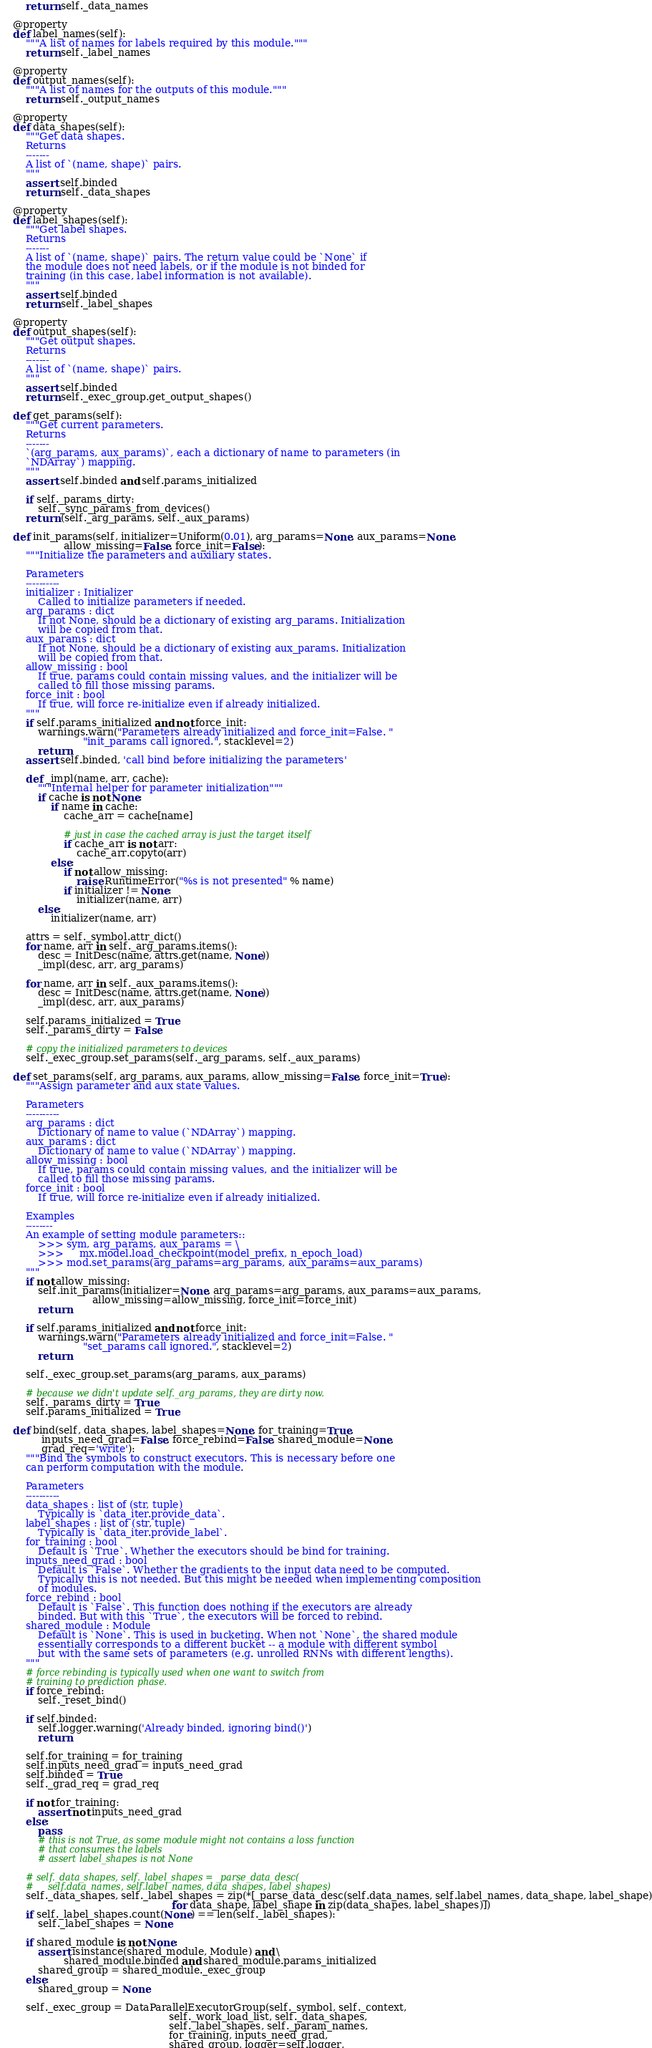Convert code to text. <code><loc_0><loc_0><loc_500><loc_500><_Python_>        return self._data_names

    @property
    def label_names(self):
        """A list of names for labels required by this module."""
        return self._label_names

    @property
    def output_names(self):
        """A list of names for the outputs of this module."""
        return self._output_names

    @property
    def data_shapes(self):
        """Get data shapes.
        Returns
        -------
        A list of `(name, shape)` pairs.
        """
        assert self.binded
        return self._data_shapes

    @property
    def label_shapes(self):
        """Get label shapes.
        Returns
        -------
        A list of `(name, shape)` pairs. The return value could be `None` if
        the module does not need labels, or if the module is not binded for
        training (in this case, label information is not available).
        """
        assert self.binded
        return self._label_shapes

    @property
    def output_shapes(self):
        """Get output shapes.
        Returns
        -------
        A list of `(name, shape)` pairs.
        """
        assert self.binded
        return self._exec_group.get_output_shapes()

    def get_params(self):
        """Get current parameters.
        Returns
        -------
        `(arg_params, aux_params)`, each a dictionary of name to parameters (in
        `NDArray`) mapping.
        """
        assert self.binded and self.params_initialized

        if self._params_dirty:
            self._sync_params_from_devices()
        return (self._arg_params, self._aux_params)

    def init_params(self, initializer=Uniform(0.01), arg_params=None, aux_params=None,
                    allow_missing=False, force_init=False):
        """Initialize the parameters and auxiliary states.

        Parameters
        ----------
        initializer : Initializer
            Called to initialize parameters if needed.
        arg_params : dict
            If not None, should be a dictionary of existing arg_params. Initialization
            will be copied from that.
        aux_params : dict
            If not None, should be a dictionary of existing aux_params. Initialization
            will be copied from that.
        allow_missing : bool
            If true, params could contain missing values, and the initializer will be
            called to fill those missing params.
        force_init : bool
            If true, will force re-initialize even if already initialized.
        """
        if self.params_initialized and not force_init:
            warnings.warn("Parameters already initialized and force_init=False. "
                          "init_params call ignored.", stacklevel=2)
            return
        assert self.binded, 'call bind before initializing the parameters'

        def _impl(name, arr, cache):
            """Internal helper for parameter initialization"""
            if cache is not None:
                if name in cache:
                    cache_arr = cache[name]

                    # just in case the cached array is just the target itself
                    if cache_arr is not arr:
                        cache_arr.copyto(arr)
                else:
                    if not allow_missing:
                        raise RuntimeError("%s is not presented" % name)
                    if initializer != None:
                        initializer(name, arr)
            else:
                initializer(name, arr)

        attrs = self._symbol.attr_dict()
        for name, arr in self._arg_params.items():
            desc = InitDesc(name, attrs.get(name, None))
            _impl(desc, arr, arg_params)

        for name, arr in self._aux_params.items():
            desc = InitDesc(name, attrs.get(name, None))
            _impl(desc, arr, aux_params)

        self.params_initialized = True
        self._params_dirty = False

        # copy the initialized parameters to devices
        self._exec_group.set_params(self._arg_params, self._aux_params)

    def set_params(self, arg_params, aux_params, allow_missing=False, force_init=True):
        """Assign parameter and aux state values.

        Parameters
        ----------
        arg_params : dict
            Dictionary of name to value (`NDArray`) mapping.
        aux_params : dict
            Dictionary of name to value (`NDArray`) mapping.
        allow_missing : bool
            If true, params could contain missing values, and the initializer will be
            called to fill those missing params.
        force_init : bool
            If true, will force re-initialize even if already initialized.

        Examples
        --------
        An example of setting module parameters::
            >>> sym, arg_params, aux_params = \
            >>>     mx.model.load_checkpoint(model_prefix, n_epoch_load)
            >>> mod.set_params(arg_params=arg_params, aux_params=aux_params)
        """
        if not allow_missing:
            self.init_params(initializer=None, arg_params=arg_params, aux_params=aux_params,
                             allow_missing=allow_missing, force_init=force_init)
            return

        if self.params_initialized and not force_init:
            warnings.warn("Parameters already initialized and force_init=False. "
                          "set_params call ignored.", stacklevel=2)
            return

        self._exec_group.set_params(arg_params, aux_params)

        # because we didn't update self._arg_params, they are dirty now.
        self._params_dirty = True
        self.params_initialized = True

    def bind(self, data_shapes, label_shapes=None, for_training=True,
             inputs_need_grad=False, force_rebind=False, shared_module=None,
             grad_req='write'):
        """Bind the symbols to construct executors. This is necessary before one
        can perform computation with the module.

        Parameters
        ----------
        data_shapes : list of (str, tuple)
            Typically is `data_iter.provide_data`.
        label_shapes : list of (str, tuple)
            Typically is `data_iter.provide_label`.
        for_training : bool
            Default is `True`. Whether the executors should be bind for training.
        inputs_need_grad : bool
            Default is `False`. Whether the gradients to the input data need to be computed.
            Typically this is not needed. But this might be needed when implementing composition
            of modules.
        force_rebind : bool
            Default is `False`. This function does nothing if the executors are already
            binded. But with this `True`, the executors will be forced to rebind.
        shared_module : Module
            Default is `None`. This is used in bucketing. When not `None`, the shared module
            essentially corresponds to a different bucket -- a module with different symbol
            but with the same sets of parameters (e.g. unrolled RNNs with different lengths).
        """
        # force rebinding is typically used when one want to switch from
        # training to prediction phase.
        if force_rebind:
            self._reset_bind()

        if self.binded:
            self.logger.warning('Already binded, ignoring bind()')
            return

        self.for_training = for_training
        self.inputs_need_grad = inputs_need_grad
        self.binded = True
        self._grad_req = grad_req

        if not for_training:
            assert not inputs_need_grad
        else:
            pass
            # this is not True, as some module might not contains a loss function
            # that consumes the labels
            # assert label_shapes is not None

        # self._data_shapes, self._label_shapes = _parse_data_desc(
        #     self.data_names, self.label_names, data_shapes, label_shapes)
        self._data_shapes, self._label_shapes = zip(*[_parse_data_desc(self.data_names, self.label_names, data_shape, label_shape)
                                                      for data_shape, label_shape in zip(data_shapes, label_shapes)])
        if self._label_shapes.count(None) == len(self._label_shapes):
            self._label_shapes = None

        if shared_module is not None:
            assert isinstance(shared_module, Module) and \
                    shared_module.binded and shared_module.params_initialized
            shared_group = shared_module._exec_group
        else:
            shared_group = None

        self._exec_group = DataParallelExecutorGroup(self._symbol, self._context,
                                                     self._work_load_list, self._data_shapes,
                                                     self._label_shapes, self._param_names,
                                                     for_training, inputs_need_grad,
                                                     shared_group, logger=self.logger,</code> 